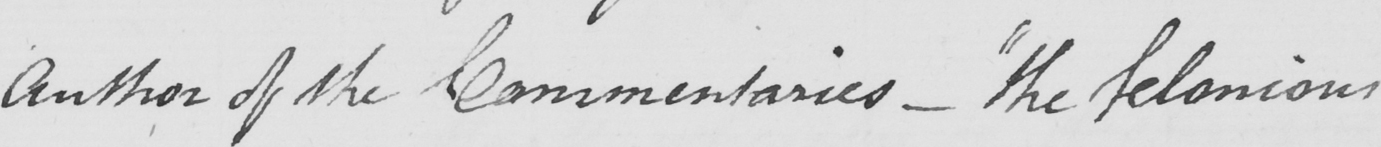Can you tell me what this handwritten text says? Author of the Commentaries  _   " the felonious 